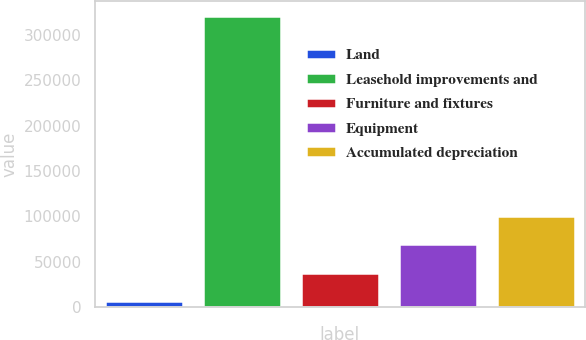<chart> <loc_0><loc_0><loc_500><loc_500><bar_chart><fcel>Land<fcel>Leasehold improvements and<fcel>Furniture and fixtures<fcel>Equipment<fcel>Accumulated depreciation<nl><fcel>6557<fcel>320941<fcel>37995.4<fcel>69433.8<fcel>100872<nl></chart> 